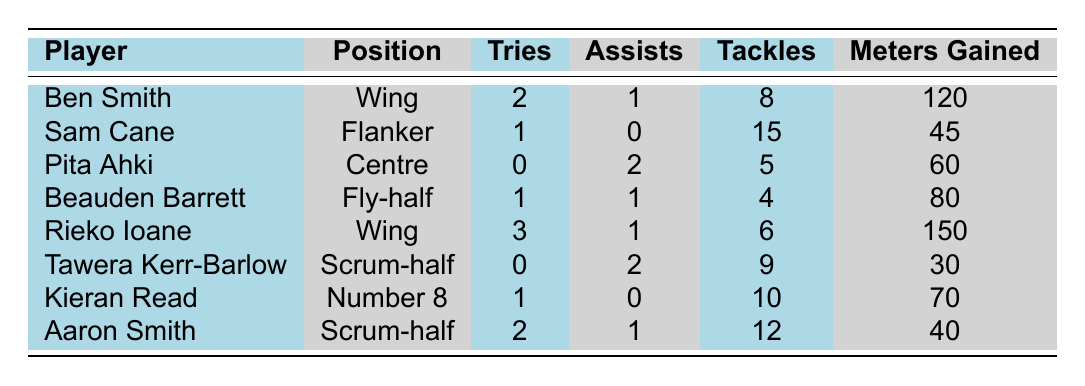What is the total number of tries scored by all players in the table? Adding up the tries for each player: 2 (Ben Smith) + 1 (Sam Cane) + 0 (Pita Ahki) + 1 (Beauden Barrett) + 3 (Rieko Ioane) + 0 (Tawera Kerr-Barlow) + 1 (Kieran Read) + 2 (Aaron Smith) = 10
Answer: 10 Which player had the most tackles in a single match? Looking at the tackles column, Sam Cane had 15 tackles, which is the highest among all the players listed.
Answer: Sam Cane Did any player score more than 2 tries in a match? Yes, Rieko Ioane scored 3 tries in the match against Argentina, which is more than 2.
Answer: Yes What is the average number of meters gained by the players? Calculate the total meters gained: 120 + 45 + 60 + 80 + 150 + 30 + 70 + 40 = 595. There are 8 players, so the average is 595/8 = 74.375.
Answer: 74.375 How many players had at least 1 assist in their match? Filter the assist column for players with assists; Ben Smith (1), Pita Ahki (2), Beauden Barrett (1), Rieko Ioane (1), and Tawera Kerr-Barlow (2) had assists, making a total of 5 players.
Answer: 5 Which player had the fewest meters gained? Tawera Kerr-Barlow had the fewest meters gained with a total of 30.
Answer: Tawera Kerr-Barlow What was the highest number of tries scored by a single player in one match? Rieko Ioane scored the highest with 3 tries, in the match against Argentina.
Answer: 3 Is there a player who neither scored tries nor conceded penalties? Yes, both Tawera Kerr-Barlow and Pita Ahki did not score tries and conceded no penalties.
Answer: Yes Which position had the highest total number of tackles in the matches? Sum tackles by position: Wing = 14, Flanker = 15, Centre = 5, Fly-half = 4, Scrum-half = 21, Number 8 = 10. Scrum-half has the highest tackles with a total of 21.
Answer: Scrum-half How many players scored exactly 1 try? The players who scored exactly 1 try are Ben Smith, Beauden Barrett, and Kieran Read, totaling 3 players.
Answer: 3 